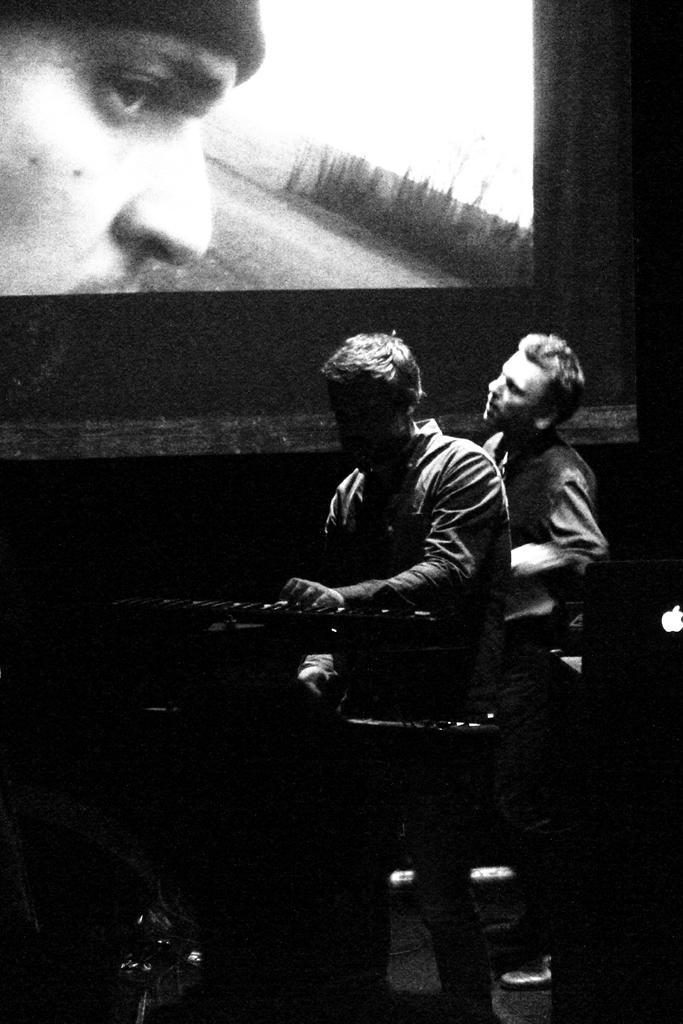Can you describe this image briefly? In this image I can see there are two persons visible in front of the screen and at the top I can see the screen , on the screen I can see person image and in the middle I can see an equipment. 